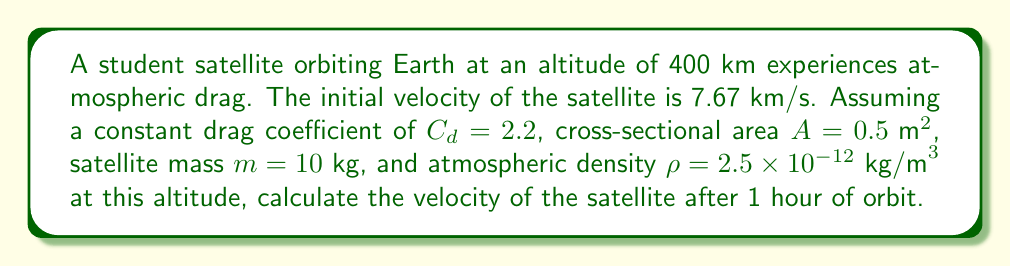Provide a solution to this math problem. To solve this problem, we'll use the equation for drag force and the principle of energy conservation.

Step 1: Calculate the drag force using the drag equation:
$$F_d = \frac{1}{2} \rho v^2 C_d A$$

Step 2: Calculate the work done by drag force over one orbit:
$$W = F_d \cdot 2\pi r$$
where $r$ is the orbital radius (Earth radius + altitude).

Step 3: Calculate the change in kinetic energy:
$$\Delta KE = -W$$

Step 4: Use the work-energy theorem to find the new velocity:
$$\frac{1}{2}mv_f^2 = \frac{1}{2}mv_i^2 - W$$

Step 5: Solve for $v_f$:
$$v_f = \sqrt{v_i^2 - \frac{2W}{m}}$$

Plugging in the values:
$\rho = 2.5 \times 10^{-12} \text{ kg/m}^3$
$v_i = 7670 \text{ m/s}$
$C_d = 2.2$
$A = 0.5 \text{ m}^2$
$r = 6371000 \text{ m} + 400000 \text{ m} = 6771000 \text{ m}$
$m = 10 \text{ kg}$

$$F_d = \frac{1}{2} (2.5 \times 10^{-12})(7670^2)(2.2)(0.5) = 1.616 \times 10^{-4} \text{ N}$$

$$W = (1.616 \times 10^{-4})(2\pi)(6771000) = 6.870 \text{ J}$$

$$v_f = \sqrt{7670^2 - \frac{2(6.870)}{10}} = 7669.9999 \text{ m/s}$$

Converting to km/s: $v_f = 7.6700 \text{ km/s}$
Answer: 7.6700 km/s 